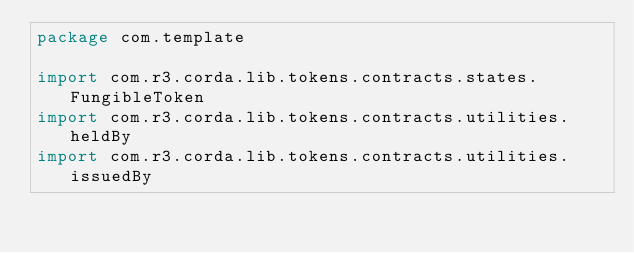Convert code to text. <code><loc_0><loc_0><loc_500><loc_500><_Kotlin_>package com.template

import com.r3.corda.lib.tokens.contracts.states.FungibleToken
import com.r3.corda.lib.tokens.contracts.utilities.heldBy
import com.r3.corda.lib.tokens.contracts.utilities.issuedBy</code> 